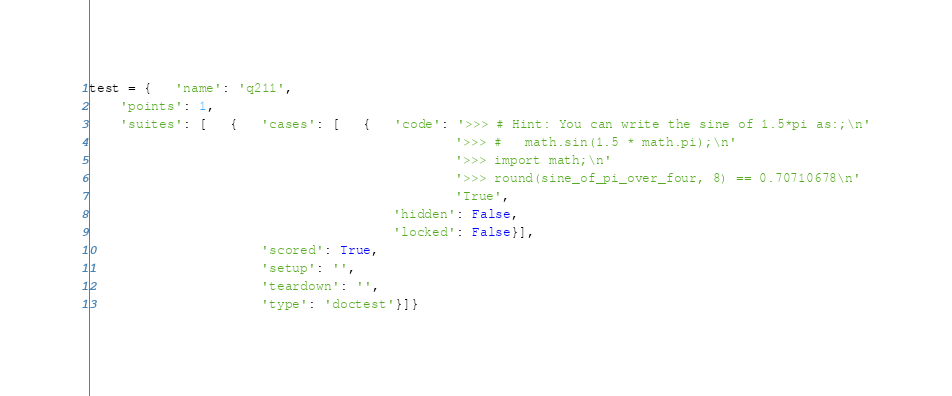Convert code to text. <code><loc_0><loc_0><loc_500><loc_500><_Python_>test = {   'name': 'q211',
    'points': 1,
    'suites': [   {   'cases': [   {   'code': '>>> # Hint: You can write the sine of 1.5*pi as:;\n'
                                               '>>> #   math.sin(1.5 * math.pi);\n'
                                               '>>> import math;\n'
                                               '>>> round(sine_of_pi_over_four, 8) == 0.70710678\n'
                                               'True',
                                       'hidden': False,
                                       'locked': False}],
                      'scored': True,
                      'setup': '',
                      'teardown': '',
                      'type': 'doctest'}]}
</code> 